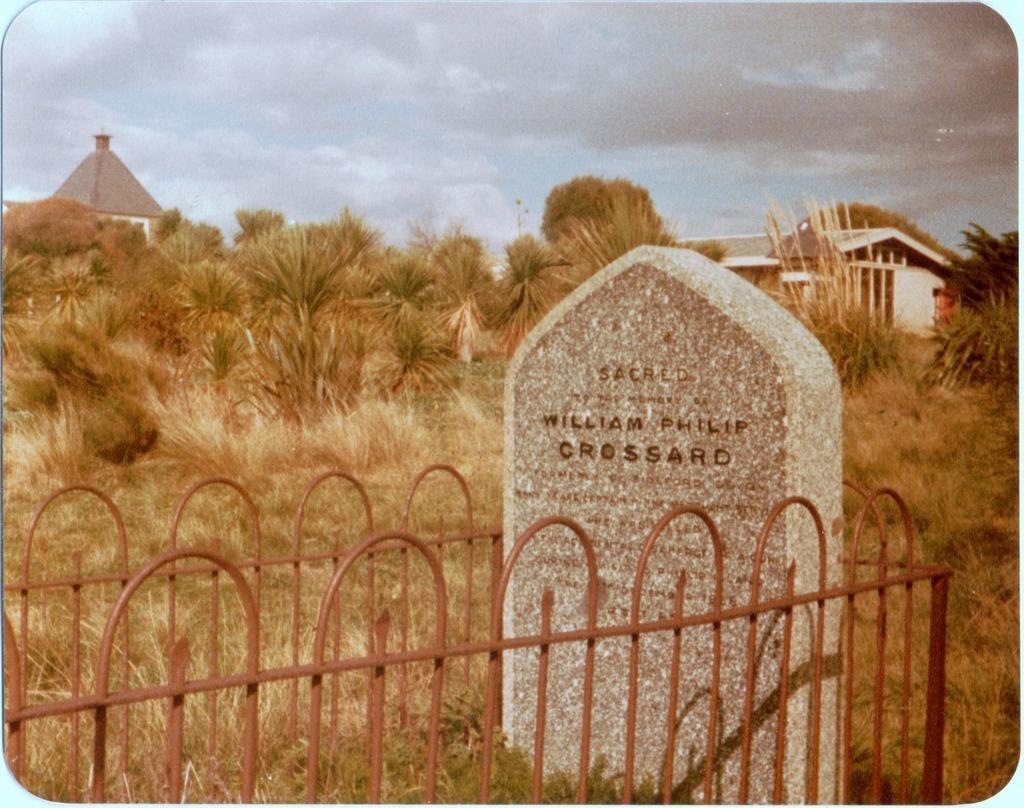Can you describe this image briefly? In the center of the image we can see a stone with text on it and railing. In the background of the image there are trees, houses, sky and grass. 